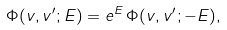<formula> <loc_0><loc_0><loc_500><loc_500>\Phi ( v , v ^ { \prime } ; E ) = e ^ { E } \, \Phi ( v , v ^ { \prime } ; - E ) ,</formula> 